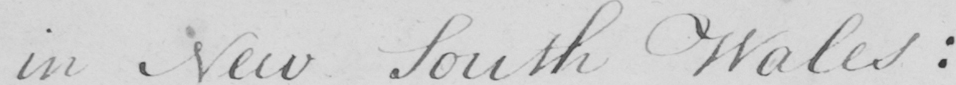Can you read and transcribe this handwriting? in New South Wales : 